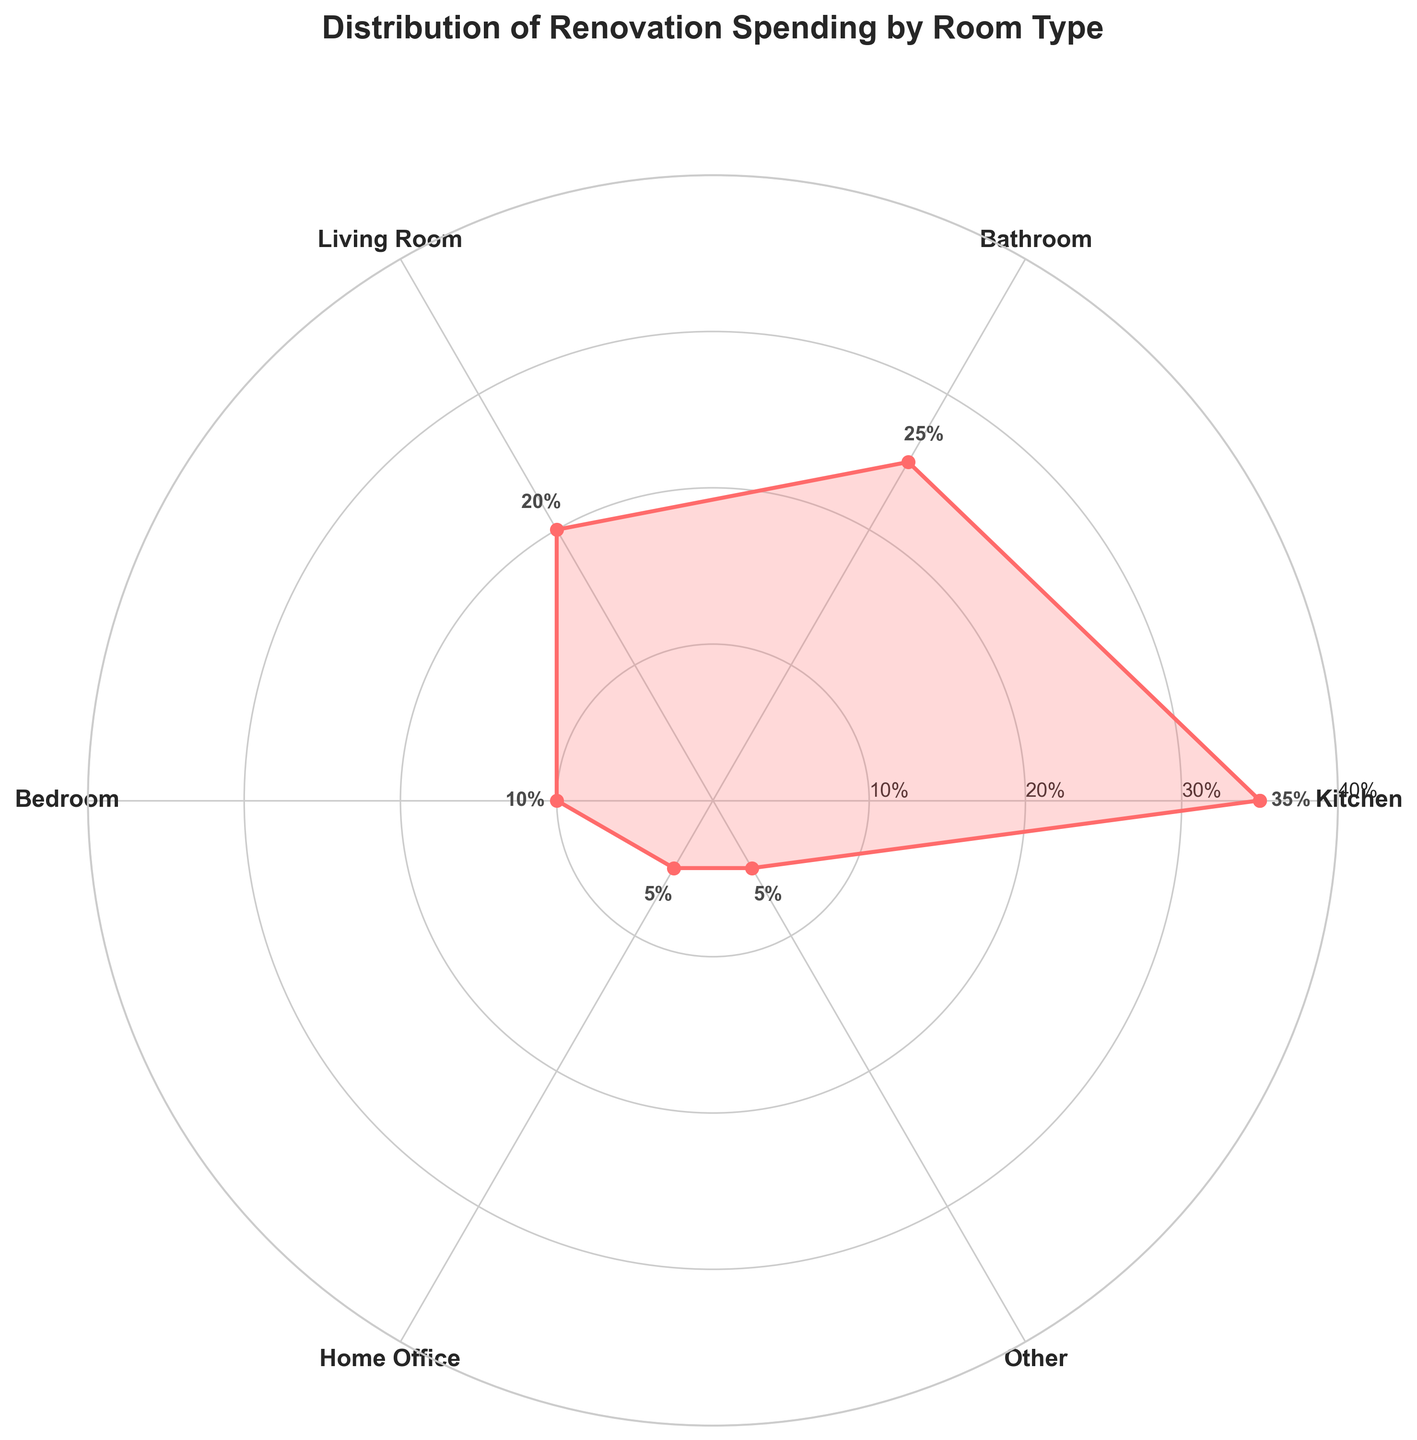what does the title of the chart say? Read the title located at the top of the figure, which provides a summary of what the chart is about.
Answer: Distribution of Renovation Spending by Room Type what color is used to plot the data in the chart? Identify the color used for the data points and shaded area in the chart by looking at the primary color on the figure.
Answer: Red which room category has the highest spending percentage? Examine the room categories and their corresponding spending percentages to determine which one has the maximum value.
Answer: Kitchen what is the percentage spent on the bathroom? Locate the data point for the bathroom on the chart and read the percentage value associated with it.
Answer: 25% how many room categories have a spending percentage of 10% or less? Identify all room categories on the chart and count the ones with spending percentages of 10% or less.
Answer: Two (Bedroom, Home Office) what is the average spending percentage for the kitchen and bathroom combined? Sum the spending percentages for the kitchen and bathroom, then divide by 2 to find the average.
Answer: (35% + 25%) / 2 = 30% which room type has a higher spending percentage, the living room or the home office? Compare the spending percentages for the living room and home office to see which one is larger.
Answer: Living Room what is the sum of the spending percentages for the bedroom and home office? Add the spending percentages for the bedroom and home office to find the total.
Answer: 10% + 5% = 15% how many data points are plotted on the chart, including the repeated initial point? Count the number of room types and then add one for the repeated starting point that completes the rose chart.
Answer: Six + One = Seven are there any room categories with the same spending percentage? If so, which ones? Look at the spending percentages of all room categories and identify if any are equal.
Answer: Yes, Home Office and Other (both 5%) 